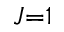<formula> <loc_0><loc_0><loc_500><loc_500>J { = } 1</formula> 